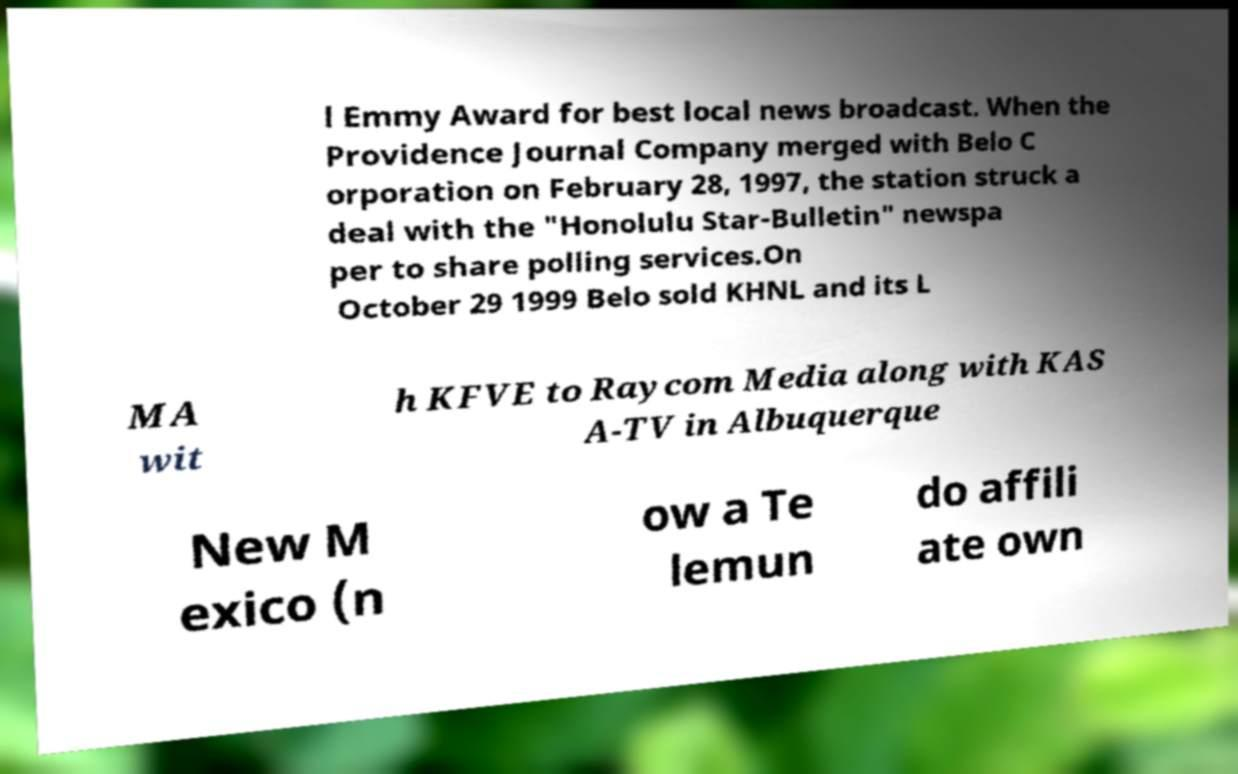Could you extract and type out the text from this image? l Emmy Award for best local news broadcast. When the Providence Journal Company merged with Belo C orporation on February 28, 1997, the station struck a deal with the "Honolulu Star-Bulletin" newspa per to share polling services.On October 29 1999 Belo sold KHNL and its L MA wit h KFVE to Raycom Media along with KAS A-TV in Albuquerque New M exico (n ow a Te lemun do affili ate own 